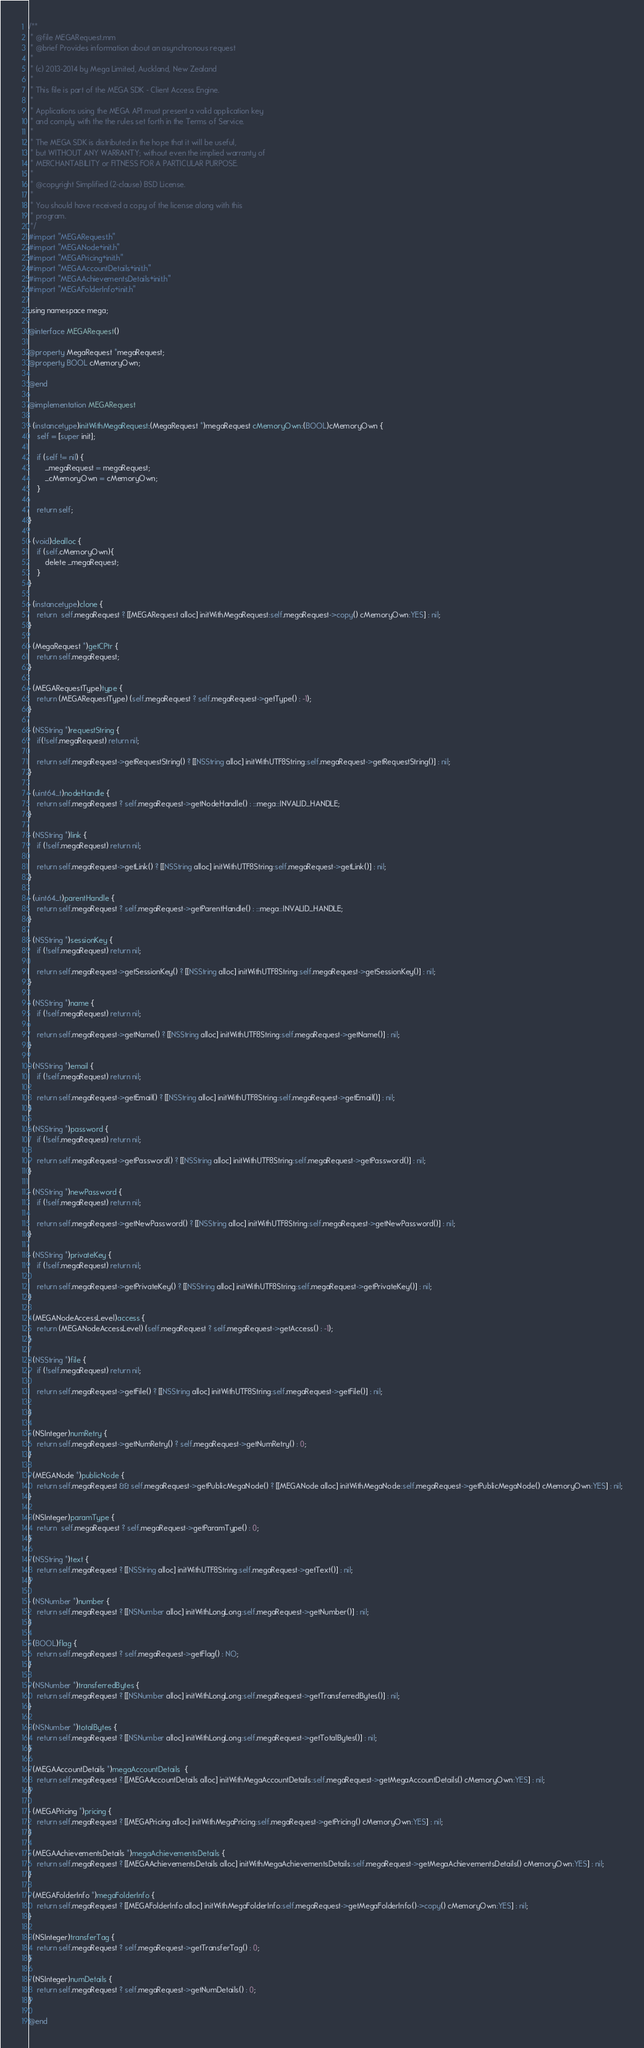Convert code to text. <code><loc_0><loc_0><loc_500><loc_500><_ObjectiveC_>/**
 * @file MEGARequest.mm
 * @brief Provides information about an asynchronous request
 *
 * (c) 2013-2014 by Mega Limited, Auckland, New Zealand
 *
 * This file is part of the MEGA SDK - Client Access Engine.
 *
 * Applications using the MEGA API must present a valid application key
 * and comply with the the rules set forth in the Terms of Service.
 *
 * The MEGA SDK is distributed in the hope that it will be useful,
 * but WITHOUT ANY WARRANTY; without even the implied warranty of
 * MERCHANTABILITY or FITNESS FOR A PARTICULAR PURPOSE.
 *
 * @copyright Simplified (2-clause) BSD License.
 *
 * You should have received a copy of the license along with this
 * program.
 */
#import "MEGARequest.h"
#import "MEGANode+init.h"
#import "MEGAPricing+init.h"
#import "MEGAAccountDetails+init.h"
#import "MEGAAchievementsDetails+init.h"
#import "MEGAFolderInfo+init.h"

using namespace mega;

@interface MEGARequest()

@property MegaRequest *megaRequest;
@property BOOL cMemoryOwn;

@end

@implementation MEGARequest

- (instancetype)initWithMegaRequest:(MegaRequest *)megaRequest cMemoryOwn:(BOOL)cMemoryOwn {
    self = [super init];
    
    if (self != nil) {
        _megaRequest = megaRequest;
        _cMemoryOwn = cMemoryOwn;
    }
    
    return self;
}

- (void)dealloc {
    if (self.cMemoryOwn){
        delete _megaRequest;
    }
}

- (instancetype)clone {
    return  self.megaRequest ? [[MEGARequest alloc] initWithMegaRequest:self.megaRequest->copy() cMemoryOwn:YES] : nil;
}

- (MegaRequest *)getCPtr {
    return self.megaRequest;
}

- (MEGARequestType)type {
    return (MEGARequestType) (self.megaRequest ? self.megaRequest->getType() : -1);
}

- (NSString *)requestString {
    if(!self.megaRequest) return nil;
    
    return self.megaRequest->getRequestString() ? [[NSString alloc] initWithUTF8String:self.megaRequest->getRequestString()] : nil;
}

- (uint64_t)nodeHandle {
    return self.megaRequest ? self.megaRequest->getNodeHandle() : ::mega::INVALID_HANDLE;
}

- (NSString *)link {
    if (!self.megaRequest) return nil;
    
    return self.megaRequest->getLink() ? [[NSString alloc] initWithUTF8String:self.megaRequest->getLink()] : nil;
}

- (uint64_t)parentHandle {
    return self.megaRequest ? self.megaRequest->getParentHandle() : ::mega::INVALID_HANDLE;
}

- (NSString *)sessionKey {
    if (!self.megaRequest) return nil;
    
    return self.megaRequest->getSessionKey() ? [[NSString alloc] initWithUTF8String:self.megaRequest->getSessionKey()] : nil;
}

- (NSString *)name {
    if (!self.megaRequest) return nil;
    
    return self.megaRequest->getName() ? [[NSString alloc] initWithUTF8String:self.megaRequest->getName()] : nil;
}

- (NSString *)email {
    if (!self.megaRequest) return nil;
    
    return self.megaRequest->getEmail() ? [[NSString alloc] initWithUTF8String:self.megaRequest->getEmail()] : nil;
}

- (NSString *)password {
    if (!self.megaRequest) return nil;
    
    return self.megaRequest->getPassword() ? [[NSString alloc] initWithUTF8String:self.megaRequest->getPassword()] : nil;
}

- (NSString *)newPassword {
    if (!self.megaRequest) return nil;
    
    return self.megaRequest->getNewPassword() ? [[NSString alloc] initWithUTF8String:self.megaRequest->getNewPassword()] : nil;
}

- (NSString *)privateKey {
    if (!self.megaRequest) return nil;
    
    return self.megaRequest->getPrivateKey() ? [[NSString alloc] initWithUTF8String:self.megaRequest->getPrivateKey()] : nil;
}

- (MEGANodeAccessLevel)access {
    return (MEGANodeAccessLevel) (self.megaRequest ? self.megaRequest->getAccess() : -1);
}

- (NSString *)file {
    if (!self.megaRequest) return nil;
    
    return self.megaRequest->getFile() ? [[NSString alloc] initWithUTF8String:self.megaRequest->getFile()] : nil;
    
}

- (NSInteger)numRetry {
    return self.megaRequest->getNumRetry() ? self.megaRequest->getNumRetry() : 0;
}

- (MEGANode *)publicNode {
    return self.megaRequest && self.megaRequest->getPublicMegaNode() ? [[MEGANode alloc] initWithMegaNode:self.megaRequest->getPublicMegaNode() cMemoryOwn:YES] : nil;
}

- (NSInteger)paramType {
    return  self.megaRequest ? self.megaRequest->getParamType() : 0;
}

- (NSString *)text {
    return self.megaRequest ? [[NSString alloc] initWithUTF8String:self.megaRequest->getText()] : nil;
}

- (NSNumber *)number {
    return self.megaRequest ? [[NSNumber alloc] initWithLongLong:self.megaRequest->getNumber()] : nil;
}

- (BOOL)flag {
    return self.megaRequest ? self.megaRequest->getFlag() : NO;
}

- (NSNumber *)transferredBytes {
    return self.megaRequest ? [[NSNumber alloc] initWithLongLong:self.megaRequest->getTransferredBytes()] : nil;
}

- (NSNumber *)totalBytes {
    return self.megaRequest ? [[NSNumber alloc] initWithLongLong:self.megaRequest->getTotalBytes()] : nil;
}

- (MEGAAccountDetails *)megaAccountDetails  {
    return self.megaRequest ? [[MEGAAccountDetails alloc] initWithMegaAccountDetails:self.megaRequest->getMegaAccountDetails() cMemoryOwn:YES] : nil;
}

- (MEGAPricing *)pricing {
    return self.megaRequest ? [[MEGAPricing alloc] initWithMegaPricing:self.megaRequest->getPricing() cMemoryOwn:YES] : nil;
}

- (MEGAAchievementsDetails *)megaAchievementsDetails {
    return self.megaRequest ? [[MEGAAchievementsDetails alloc] initWithMegaAchievementsDetails:self.megaRequest->getMegaAchievementsDetails() cMemoryOwn:YES] : nil;
}

- (MEGAFolderInfo *)megaFolderInfo {
    return self.megaRequest ? [[MEGAFolderInfo alloc] initWithMegaFolderInfo:self.megaRequest->getMegaFolderInfo()->copy() cMemoryOwn:YES] : nil;
}

- (NSInteger)transferTag {
    return self.megaRequest ? self.megaRequest->getTransferTag() : 0;
}

- (NSInteger)numDetails {
    return self.megaRequest ? self.megaRequest->getNumDetails() : 0;
}

@end
</code> 